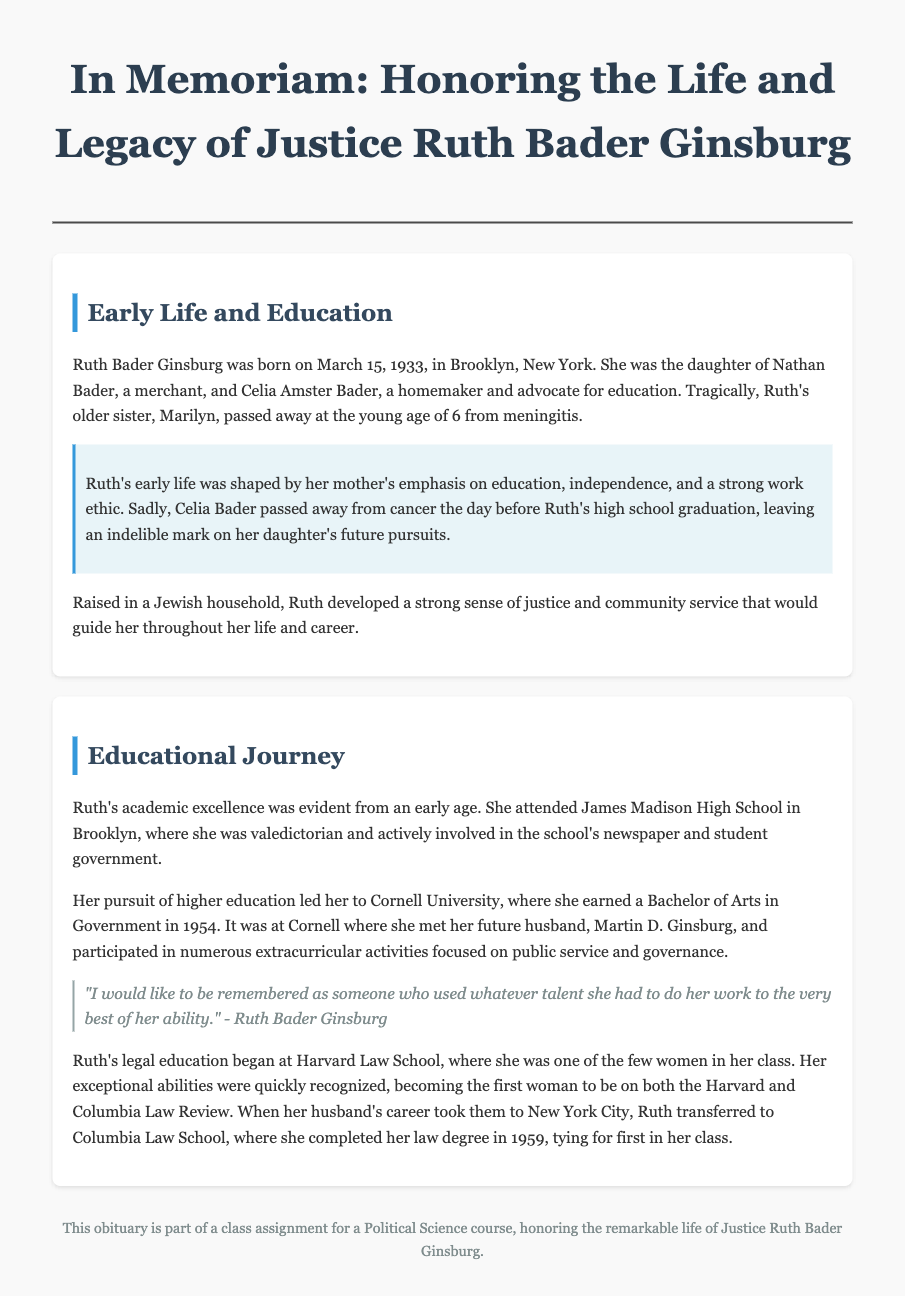What date was Ruth Bader Ginsburg born? The document states Ruth Bader Ginsburg was born on March 15, 1933.
Answer: March 15, 1933 Who were Ruth Bader Ginsburg's parents? The parents mentioned in the document are Nathan Bader and Celia Amster Bader.
Answer: Nathan Bader and Celia Amster Bader What year did Ruth graduate from Cornell University? The document specifies that Ruth earned her degree from Cornell University in 1954.
Answer: 1954 How did Ruth's mother influence her life? The document highlights that Ruth's mother emphasized education, independence, and a strong work ethic.
Answer: Education, independence, and strong work ethic What milestone did Ruth achieve in her legal education at Columbia Law School? According to the document, she tied for first in her class at Columbia Law School.
Answer: Tied for first in her class What extracurricular activities did Ruth participate in at Cornell? The document notes that she participated in activities focused on public service and governance.
Answer: Public service and governance What was Ruth Bader Ginsburg's role in high school? The document states she was valedictorian at James Madison High School.
Answer: Valedictorian What significant event happened the day before Ruth's high school graduation? The document mentions that her mother passed away from cancer the day before her graduation.
Answer: Her mother passed away from cancer 